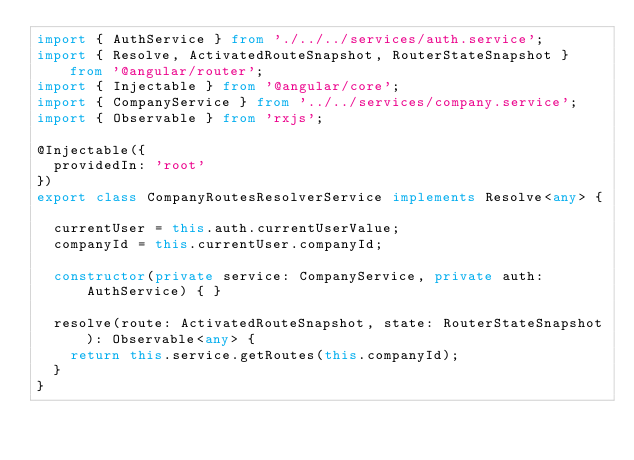<code> <loc_0><loc_0><loc_500><loc_500><_TypeScript_>import { AuthService } from './../../services/auth.service';
import { Resolve, ActivatedRouteSnapshot, RouterStateSnapshot } from '@angular/router';
import { Injectable } from '@angular/core';
import { CompanyService } from '../../services/company.service';
import { Observable } from 'rxjs';

@Injectable({
  providedIn: 'root'
})
export class CompanyRoutesResolverService implements Resolve<any> {

  currentUser = this.auth.currentUserValue;
  companyId = this.currentUser.companyId;

  constructor(private service: CompanyService, private auth: AuthService) { }

  resolve(route: ActivatedRouteSnapshot, state: RouterStateSnapshot): Observable<any> {
    return this.service.getRoutes(this.companyId);
  }
}
</code> 